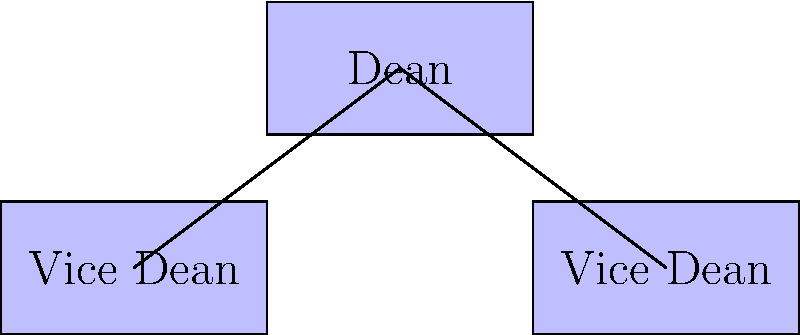Based on the organizational structure of the law faculty at the University of Boyacá shown in the diagram, how many departments are directly overseen by each Vice Dean? To answer this question, we need to analyze the hierarchical structure presented in the diagram:

1. At the top of the structure, we see the Dean of the law faculty.
2. Directly below the Dean, there are two Vice Deans, indicating a division of responsibilities.
3. The next level shows four departments: Civil Law, Criminal Law, Constitutional Law, and International Law.
4. We can observe that the departments are evenly distributed under the two Vice Deans.
5. Counting the departments under each Vice Dean, we find:
   - The left Vice Dean oversees Civil Law and Criminal Law (2 departments)
   - The right Vice Dean oversees Constitutional Law and International Law (2 departments)
6. Therefore, each Vice Dean is responsible for overseeing 2 departments.
Answer: 2 departments 